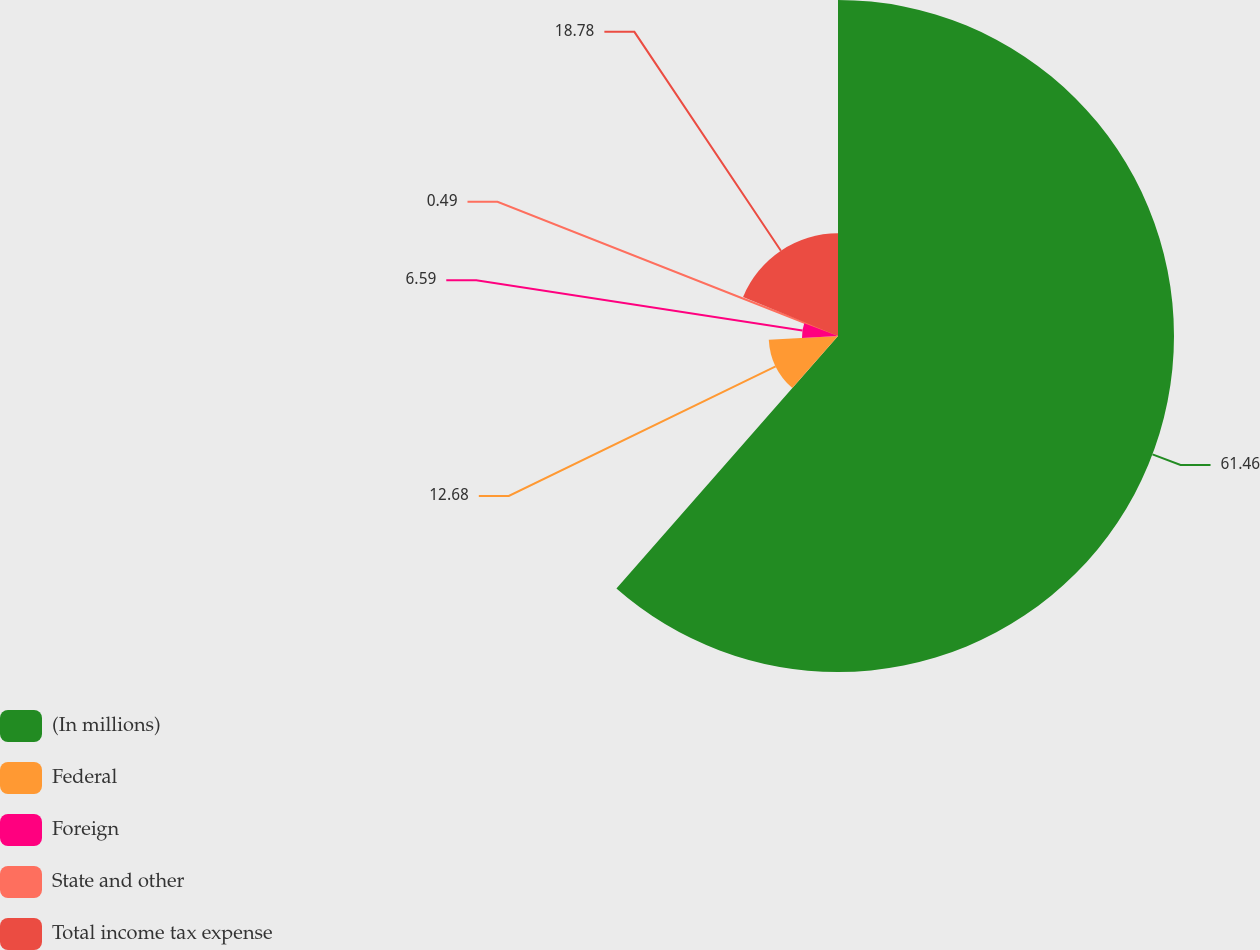<chart> <loc_0><loc_0><loc_500><loc_500><pie_chart><fcel>(In millions)<fcel>Federal<fcel>Foreign<fcel>State and other<fcel>Total income tax expense<nl><fcel>61.46%<fcel>12.68%<fcel>6.59%<fcel>0.49%<fcel>18.78%<nl></chart> 